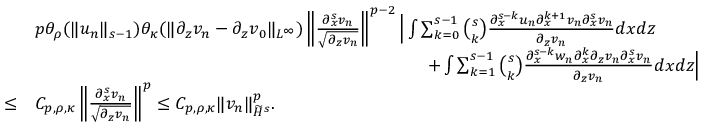Convert formula to latex. <formula><loc_0><loc_0><loc_500><loc_500>\begin{array} { r l } & { p \theta _ { \rho } ( \| u _ { n } \| _ { s - 1 } ) \theta _ { \kappa } ( \| \partial _ { z } v _ { n } - \partial _ { z } v _ { 0 } \| _ { L ^ { \infty } } ) \left \| \frac { \partial _ { x } ^ { s } v _ { n } } { \sqrt { \partial _ { z } v _ { n } } } \right \| ^ { p - 2 } \left | \int \sum _ { k = 0 } ^ { s - 1 } \binom { s } { k } \frac { \partial _ { x } ^ { s - k } u _ { n } \partial _ { x } ^ { k + 1 } v _ { n } \partial _ { x } ^ { s } v _ { n } } { \partial _ { z } v _ { n } } d x d z } \\ & { \quad + \int \sum _ { k = 1 } ^ { s - 1 } \binom { s } { k } \frac { \partial _ { x } ^ { s - k } w _ { n } \partial _ { x } ^ { k } \partial _ { z } v _ { n } \partial _ { x } ^ { s } v _ { n } } { \partial _ { z } v _ { n } } d x d z \right | } \\ { \leq } & { C _ { p , \rho , \kappa } \left \| \frac { \partial _ { x } ^ { s } v _ { n } } { \sqrt { \partial _ { z } v _ { n } } } \right \| ^ { p } \leq C _ { p , \rho , \kappa } \| v _ { n } \| _ { \widetilde { H } ^ { s } } ^ { p } . } \end{array}</formula> 